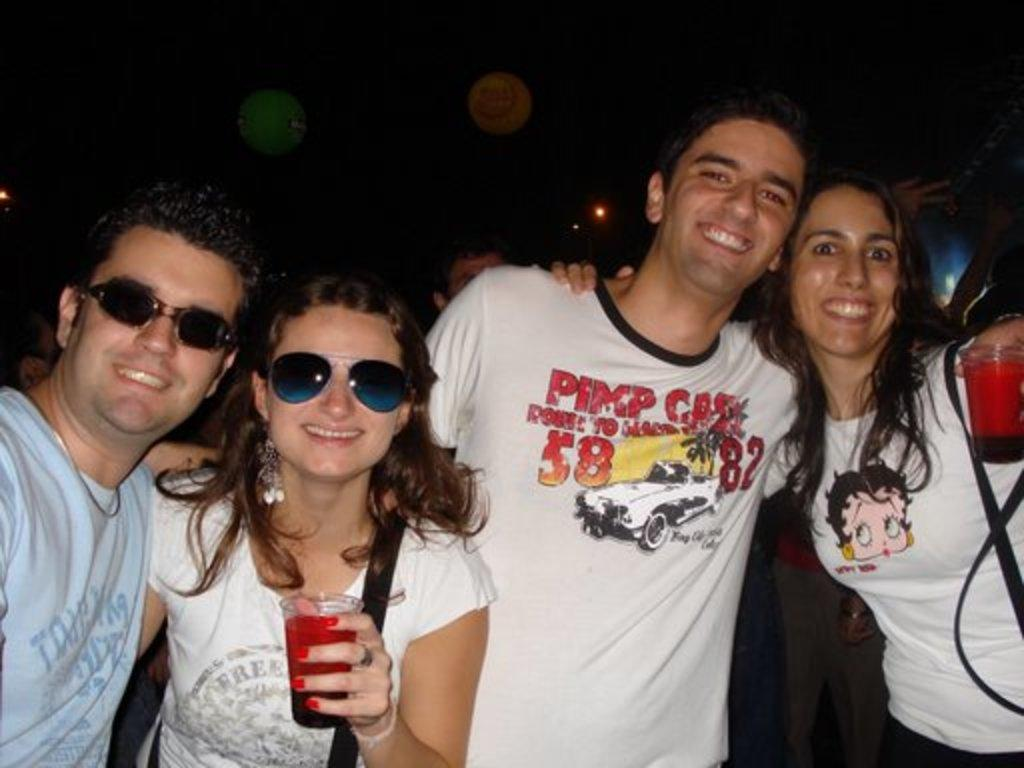How many people are in the image? There are persons standing in the image. What is the facial expression of the persons in the image? The persons are smiling. What objects are the persons holding in their hands? The persons are holding disposable tumblers in their hands. What language are the persons speaking in the image? The provided facts do not mention any specific language being spoken in the image. --- Facts: 1. There is a person sitting on a chair in the image. 2. The person is holding a book. 3. The book has a blue cover. 4. The person is wearing glasses. Absurd Topics: animal, ocean, dance Conversation: What is the person in the image doing? There is a person sitting on a chair in the image. What object is the person holding? The person is holding a book. What is the color of the book's cover? The book has a blue cover. What accessory is the person wearing? The person is wearing glasses. Reasoning: Let's think step by step in order to produce the conversation. We start by identifying the main subject in the image, which is the person sitting on a chair. Then, we describe the object the person is holding, which is a book with a blue cover. We also mention the accessory the person is wearing, which are glasses. Each question is designed to elicit a specific detail about the image that is known from the provided facts. Absurd Question/Answer: What type of animal can be seen swimming in the ocean in the image? There is no animal or ocean present in the image; it features a person sitting on a chair holding a book with a blue cover. 